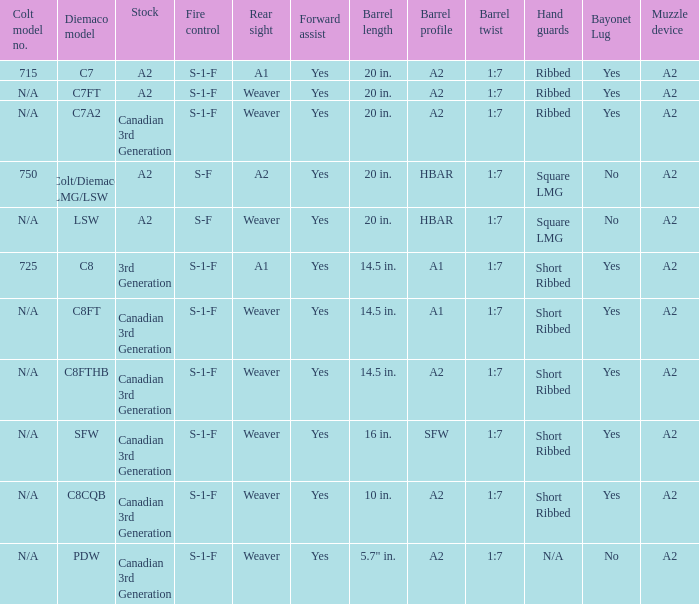Which hand shields feature an a2 barrel shape and a weaver-style rear sight? Ribbed, Ribbed, Short Ribbed, Short Ribbed, N/A. 